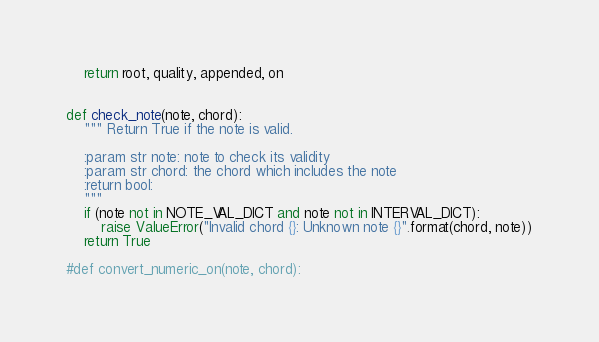<code> <loc_0><loc_0><loc_500><loc_500><_Python_>    return root, quality, appended, on


def check_note(note, chord):
    """ Return True if the note is valid.

    :param str note: note to check its validity
    :param str chord: the chord which includes the note
    :return bool:
    """
    if (note not in NOTE_VAL_DICT and note not in INTERVAL_DICT):
        raise ValueError("Invalid chord {}: Unknown note {}".format(chord, note))
    return True

#def convert_numeric_on(note, chord):

</code> 